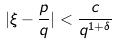Convert formula to latex. <formula><loc_0><loc_0><loc_500><loc_500>| \xi - \frac { p } { q } | < \frac { c } { q ^ { 1 + \delta } }</formula> 